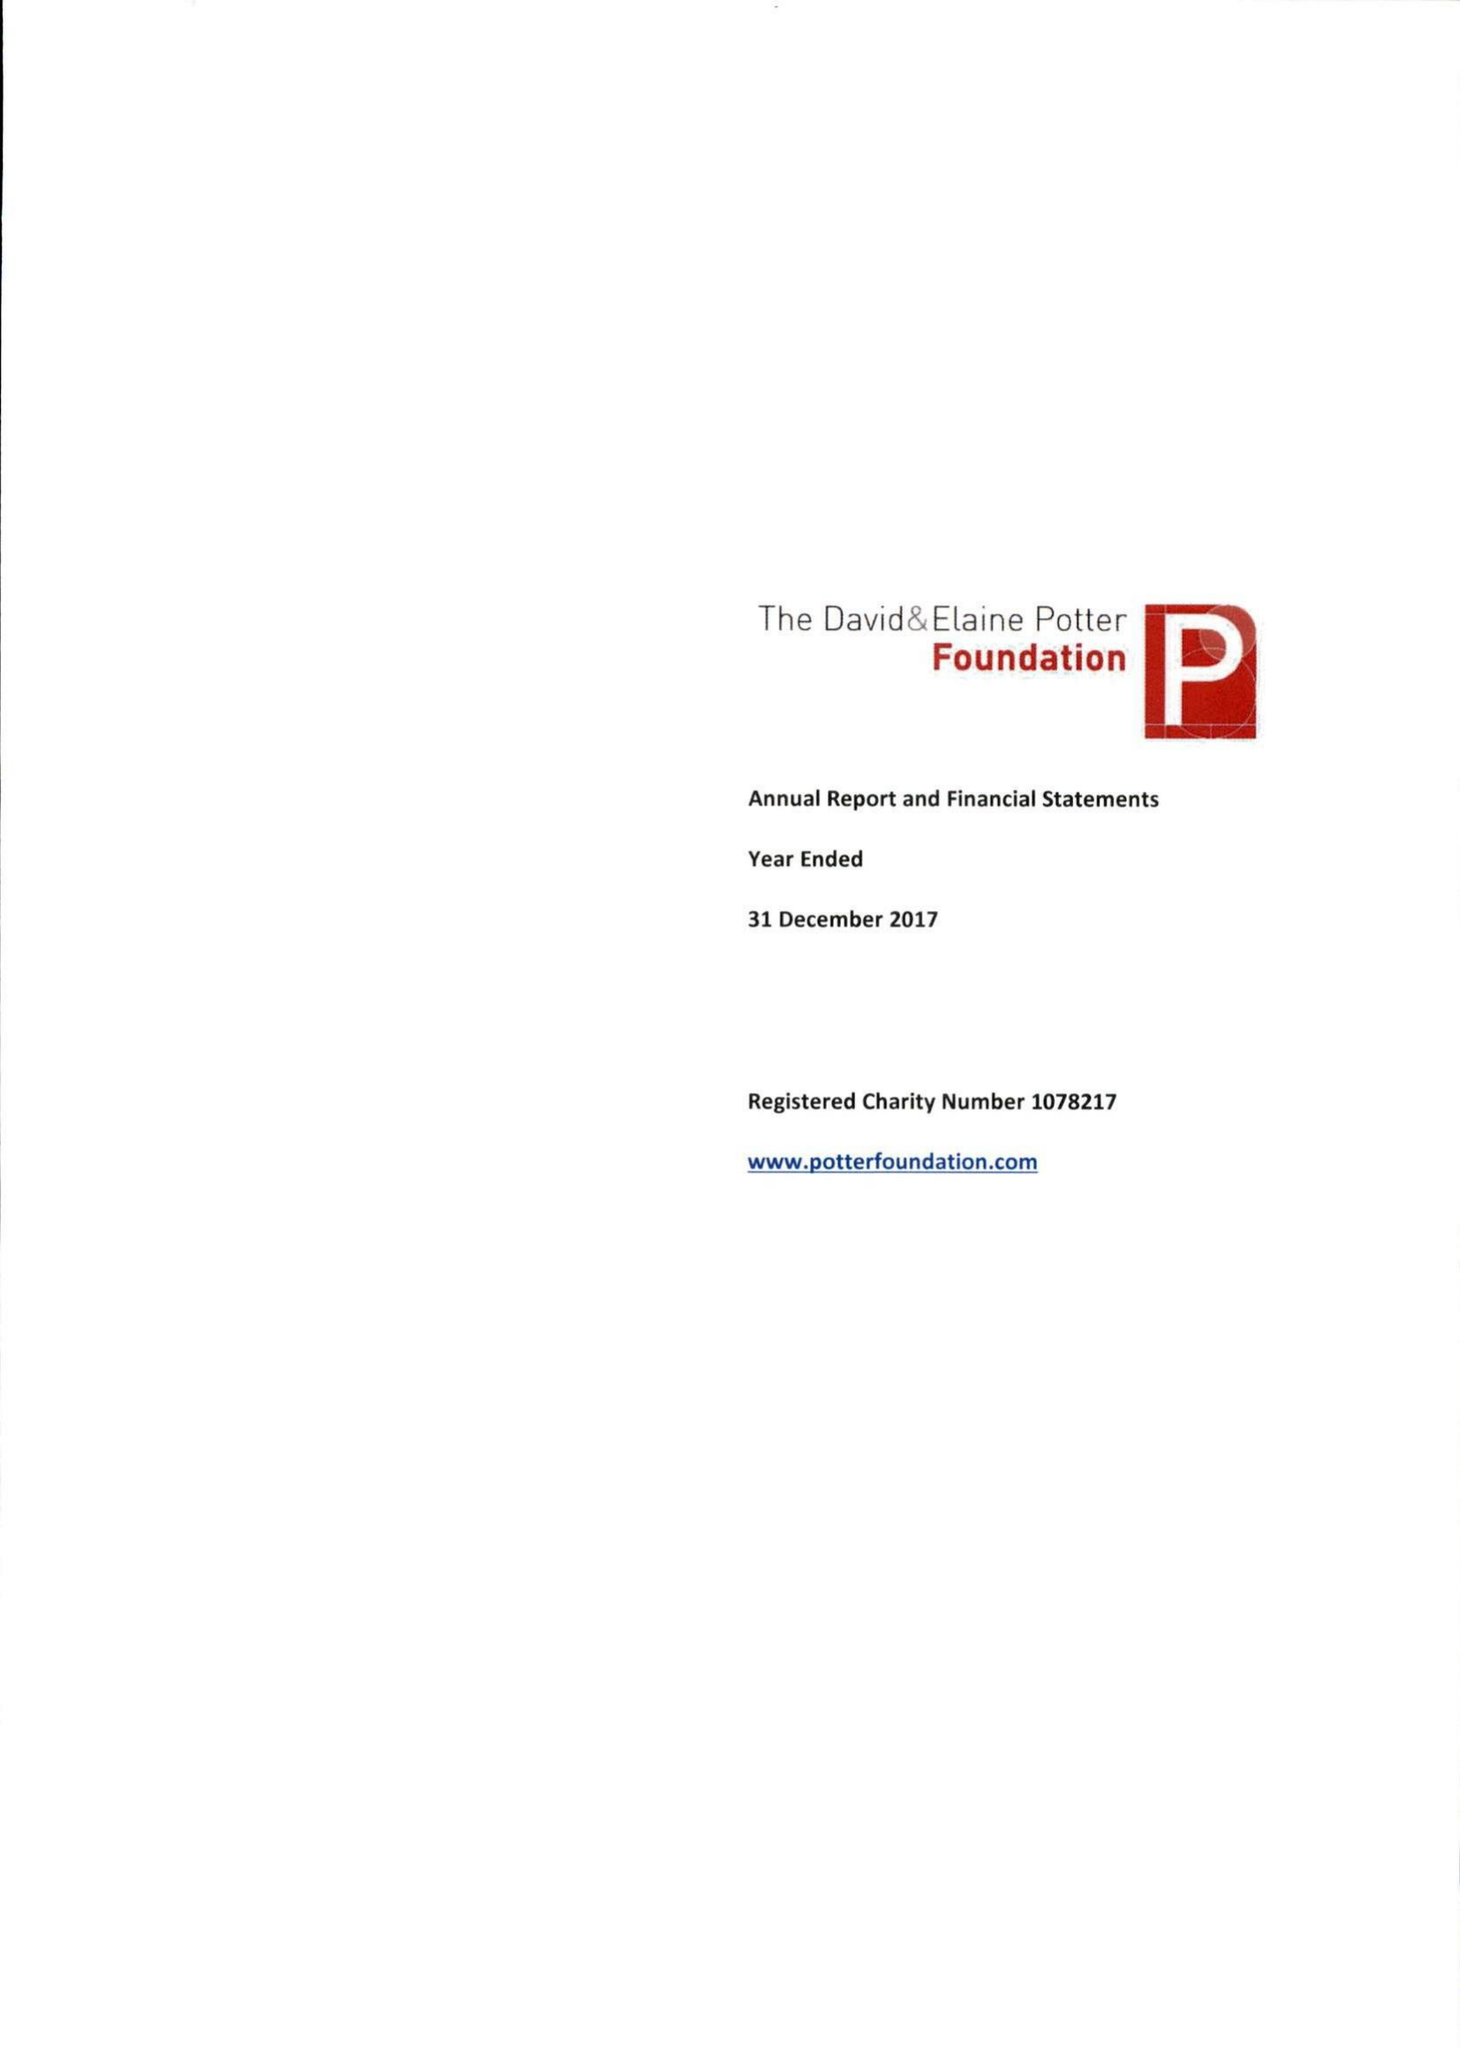What is the value for the spending_annually_in_british_pounds?
Answer the question using a single word or phrase. 1380186.00 